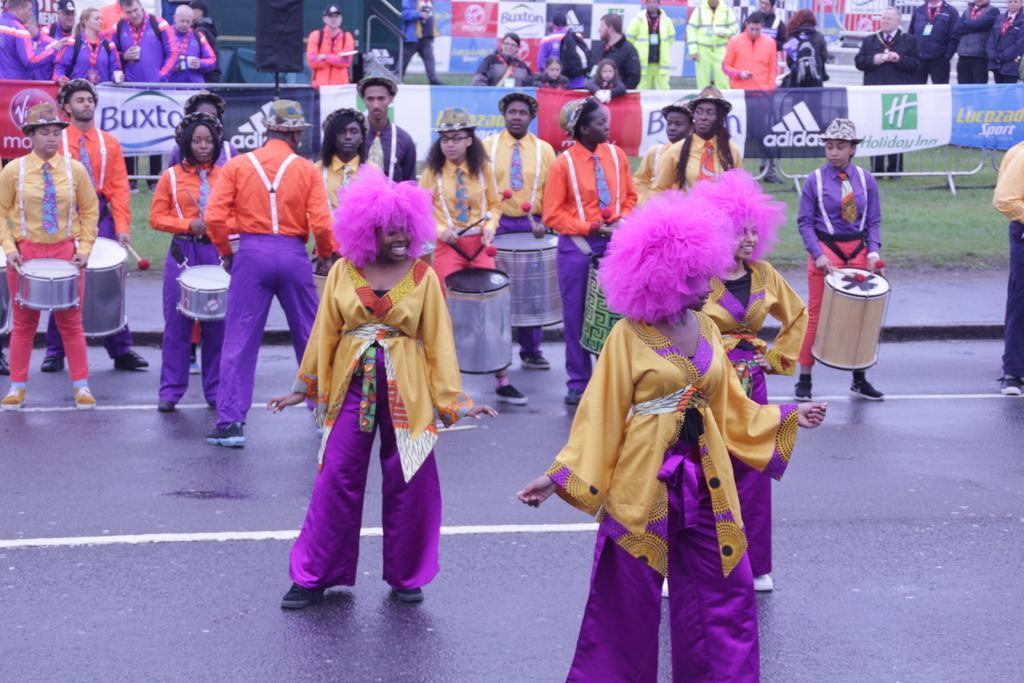Please provide a concise description of this image. In this image there are a group of people who are standing and they are playing drums. On the background there are group of people who are standing and some posters are there and in the bottom there is some grass. 